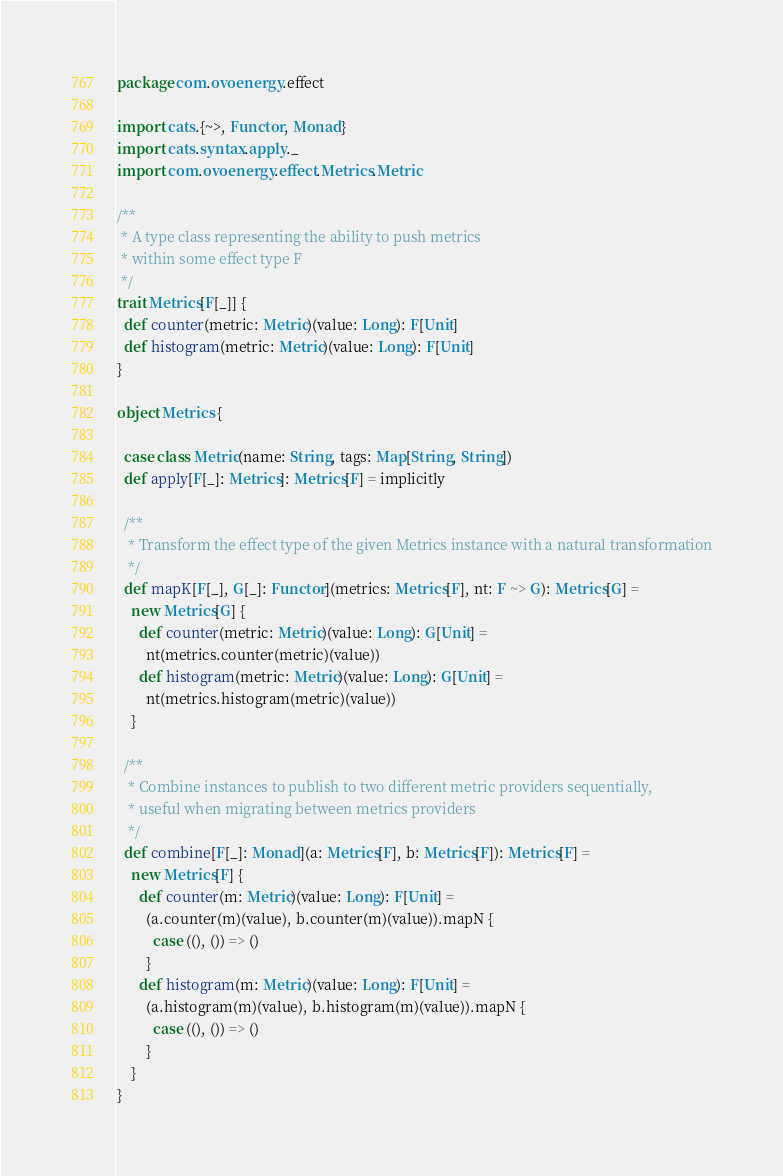<code> <loc_0><loc_0><loc_500><loc_500><_Scala_>package com.ovoenergy.effect

import cats.{~>, Functor, Monad}
import cats.syntax.apply._
import com.ovoenergy.effect.Metrics.Metric

/**
 * A type class representing the ability to push metrics
 * within some effect type F
 */
trait Metrics[F[_]] {
  def counter(metric: Metric)(value: Long): F[Unit]
  def histogram(metric: Metric)(value: Long): F[Unit]
}

object Metrics {

  case class Metric(name: String, tags: Map[String, String])
  def apply[F[_]: Metrics]: Metrics[F] = implicitly

  /**
   * Transform the effect type of the given Metrics instance with a natural transformation
   */
  def mapK[F[_], G[_]: Functor](metrics: Metrics[F], nt: F ~> G): Metrics[G] =
    new Metrics[G] {
      def counter(metric: Metric)(value: Long): G[Unit] =
        nt(metrics.counter(metric)(value))
      def histogram(metric: Metric)(value: Long): G[Unit] =
        nt(metrics.histogram(metric)(value))
    }

  /**
   * Combine instances to publish to two different metric providers sequentially,
   * useful when migrating between metrics providers
   */
  def combine[F[_]: Monad](a: Metrics[F], b: Metrics[F]): Metrics[F] =
    new Metrics[F] {
      def counter(m: Metric)(value: Long): F[Unit] =
        (a.counter(m)(value), b.counter(m)(value)).mapN {
          case ((), ()) => ()
        }
      def histogram(m: Metric)(value: Long): F[Unit] =
        (a.histogram(m)(value), b.histogram(m)(value)).mapN {
          case ((), ()) => ()
        }
    }
}
</code> 